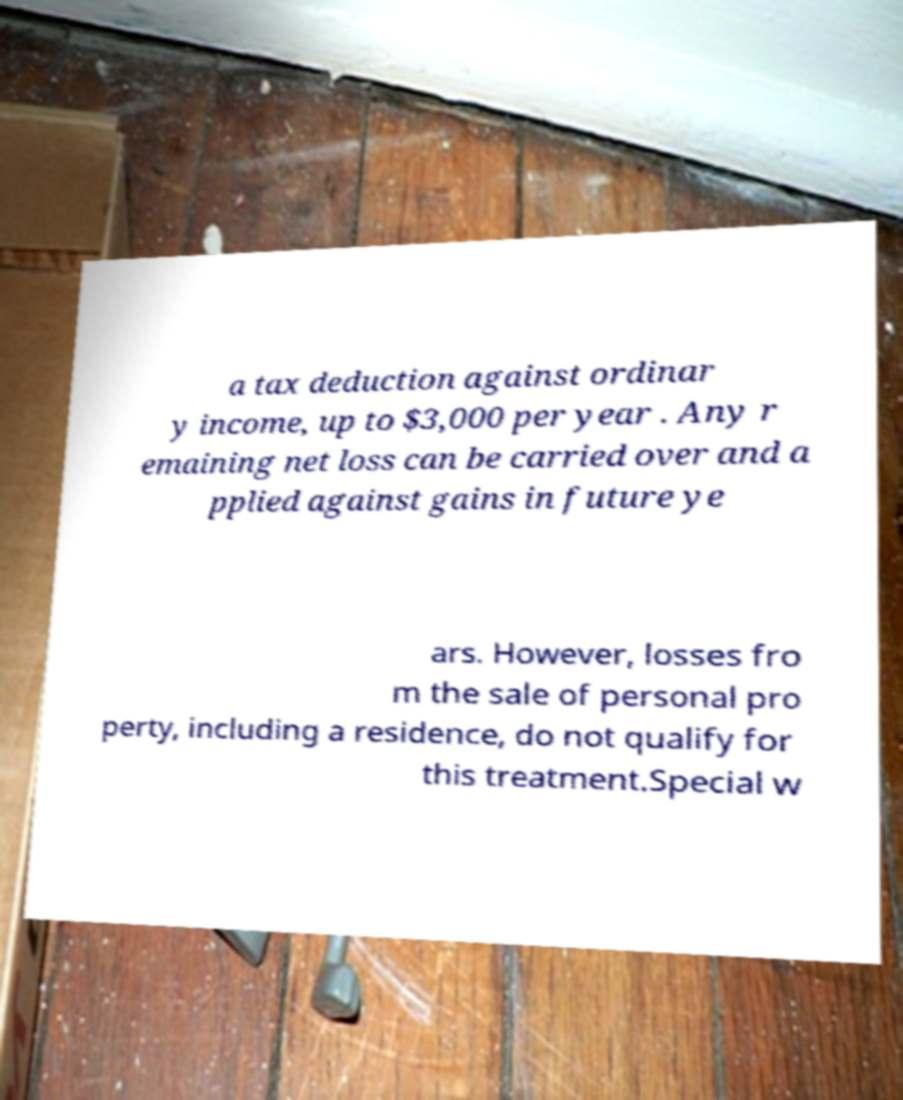What messages or text are displayed in this image? I need them in a readable, typed format. a tax deduction against ordinar y income, up to $3,000 per year . Any r emaining net loss can be carried over and a pplied against gains in future ye ars. However, losses fro m the sale of personal pro perty, including a residence, do not qualify for this treatment.Special w 